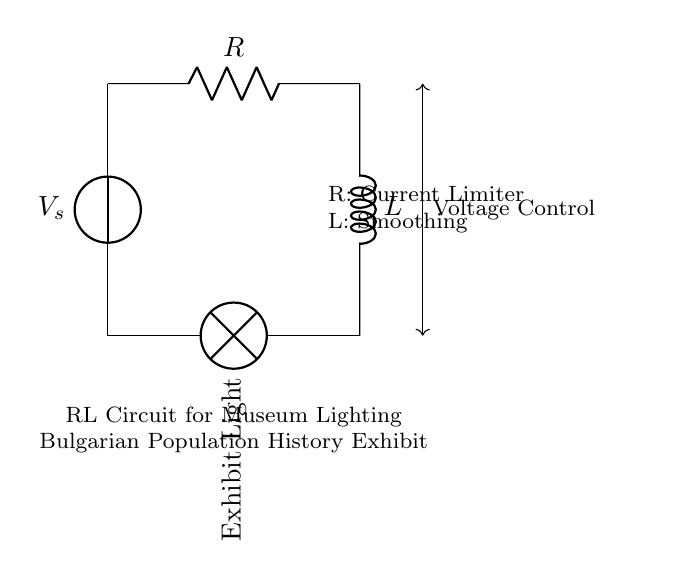What is the purpose of the resistor in this circuit? The resistor limits the current flowing through the circuit to prevent excessive current that could damage components, enhancing safety and regulating power.
Answer: Current Limiter What does the inductor do in this RL circuit? The inductor smooths out the current flow, reducing the fluctuations and providing a more stable supply to the exhibit light, crucial for maintaining uniform lighting.
Answer: Smoothing How many components are in this RL circuit? The circuit consists of three components: a voltage source, a resistor, and an inductor.
Answer: Three What type of circuit is displayed? The circuit is classified as a series RL circuit because the resistor and inductor are connected in series with the voltage source and the exhibit light.
Answer: Series RL What is the main application of this RL circuit? The main application is to regulate power in lighting systems for museum exhibits, particularly for displaying artifacts related to Bulgarian population history, ensuring stable illumination.
Answer: Power Regulation in Lighting What type of load is connected in this circuit? The load connected in this circuit is a lamp, which represents the exhibit light designed to illuminate the exhibition space effectively.
Answer: Lamp 